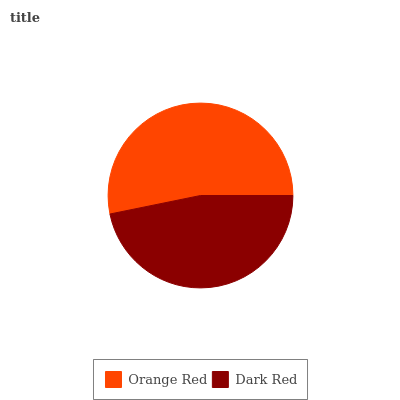Is Dark Red the minimum?
Answer yes or no. Yes. Is Orange Red the maximum?
Answer yes or no. Yes. Is Dark Red the maximum?
Answer yes or no. No. Is Orange Red greater than Dark Red?
Answer yes or no. Yes. Is Dark Red less than Orange Red?
Answer yes or no. Yes. Is Dark Red greater than Orange Red?
Answer yes or no. No. Is Orange Red less than Dark Red?
Answer yes or no. No. Is Orange Red the high median?
Answer yes or no. Yes. Is Dark Red the low median?
Answer yes or no. Yes. Is Dark Red the high median?
Answer yes or no. No. Is Orange Red the low median?
Answer yes or no. No. 